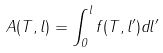<formula> <loc_0><loc_0><loc_500><loc_500>A ( T , l ) = \int _ { 0 } ^ { l } f ( T , l ^ { \prime } ) d l ^ { \prime }</formula> 